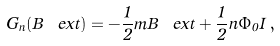<formula> <loc_0><loc_0><loc_500><loc_500>G _ { n } ( B _ { \ } e x t ) = - \frac { 1 } { 2 } m B _ { \ } e x t + \frac { 1 } { 2 } n \Phi _ { 0 } I \, ,</formula> 